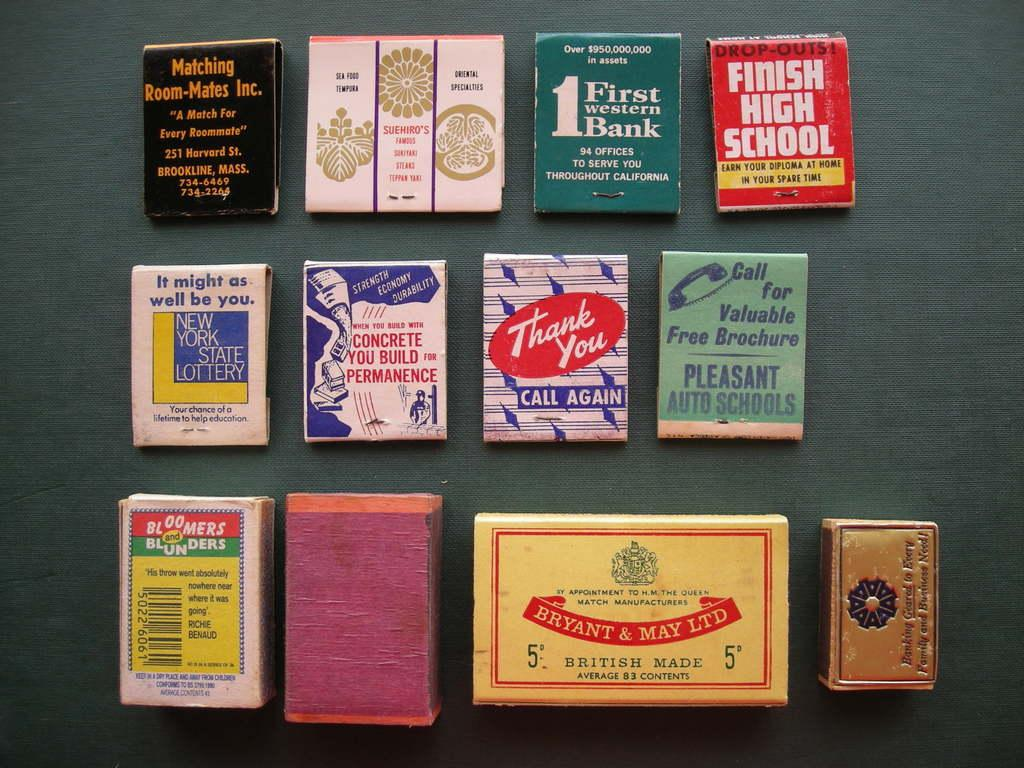<image>
Describe the image concisely. A collection of matchbooks from places like the Finish High School and First Western Bank on display. 